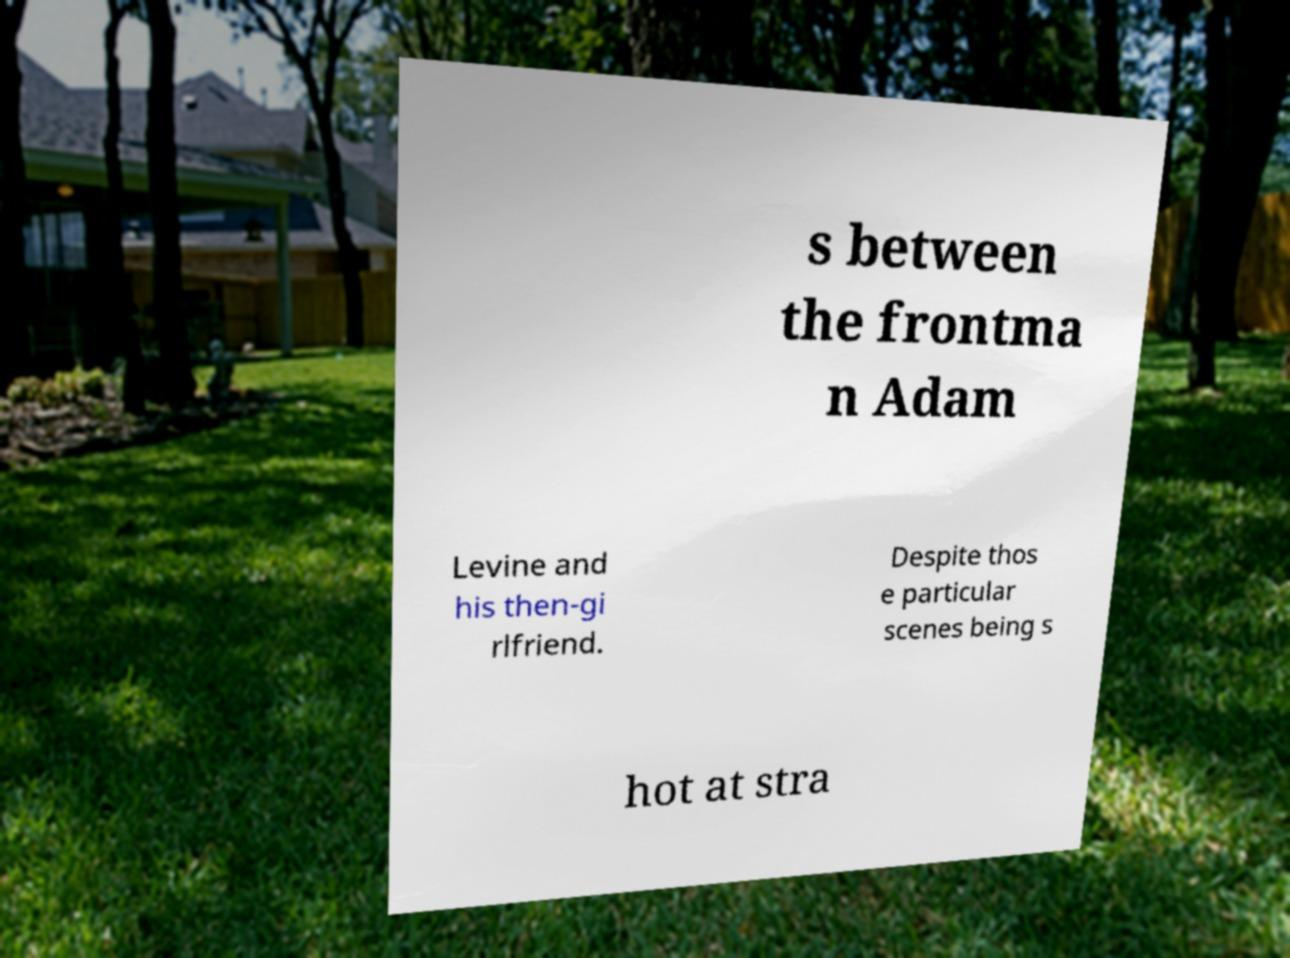Could you extract and type out the text from this image? s between the frontma n Adam Levine and his then-gi rlfriend. Despite thos e particular scenes being s hot at stra 